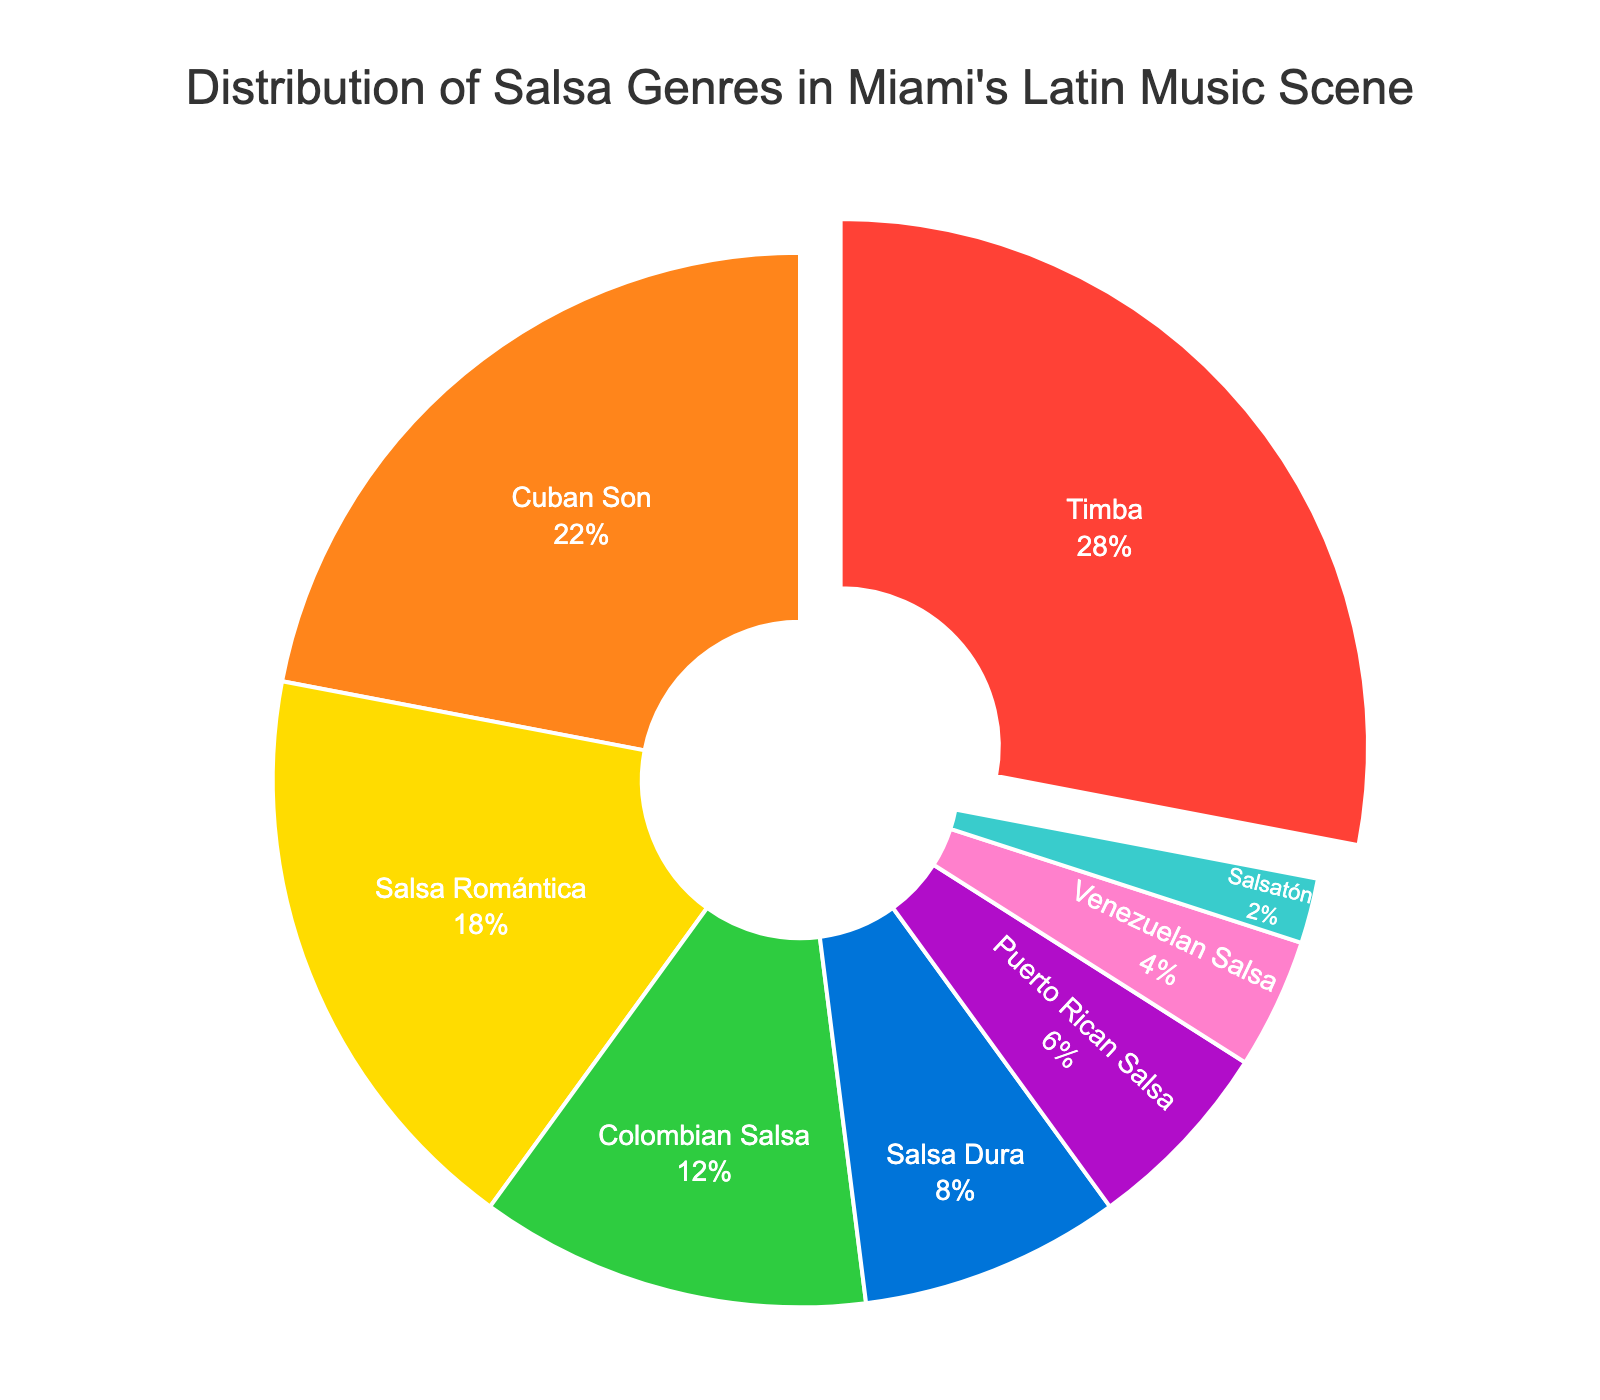Which genre has the highest percentage in Miami's salsa music scene? The genre with the highest percentage occupies the largest slice. Timba, with 28%, occupies the largest slice.
Answer: Timba How much more popular is Timba compared to Cuban Son? To determine this, subtract the percentage of Cuban Son from Timba. Timba has 28%, and Cuban Son has 22%, so 28% - 22% = 6%.
Answer: 6% What is the combined percentage of Salsa Romántica and Colombian Salsa? To find this, add the individual percentages of Salsa Romántica (18%) and Colombian Salsa (12%). 18% + 12% = 30%.
Answer: 30% Which salsa genre is the least popular in Miami? The least popular genre would be the one with the smallest percentage. Salsatón has the smallest slice with 2%.
Answer: Salsatón Is Salsa Dura more popular than Puerto Rican Salsa? Compare the percentages of Salsa Dura (8%) and Puerto Rican Salsa (6%). Salsa Dura has a larger percentage than Puerto Rican Salsa.
Answer: Yes What is the total percentage of salsa genres originating from countries other than Cuba? First, identify non-Cuban genres: Colombian Salsa (12%), Puerto Rican Salsa (6%), Venezuelan Salsa (4%), and Salsatón (2%). Sum these percentages: 12% + 6% + 4% + 2% = 24%.
Answer: 24% Which genre occupies a green-colored slice in the pie chart? The green slice is typically easier to recognize visually. According to the colors chosen for the plot, the green slice represents Colombian Salsa.
Answer: Colombian Salsa How does the popularity of Salsa Romántica compare to Salsa Dura? Compare their percentages: Salsa Romántica has 18%, while Salsa Dura has 8%. Salsa Romántica is 10% more popular.
Answer: Salsa Romántica is 10% more popular What is the difference in percentage between Cuban Son and Salsa Romántica combined versus the sum of Salsa Dura and Puerto Rican Salsa? Cuban Son (22%) + Salsa Romántica (18%) = 40%. Salsa Dura (8%) + Puerto Rican Salsa (6%) = 14%. The difference is 40% - 14% = 26%.
Answer: 26% What percentage of the pie chart is not occupied by Timba and Cuban Son? First, add the percentages of Timba (28%) and Cuban Son (22%) together. Then subtract this sum from 100%: 28% + 22% = 50%, so 100% - 50% = 50%.
Answer: 50% 